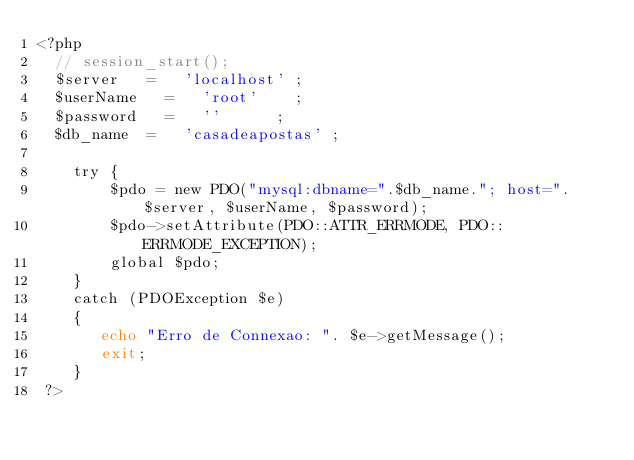Convert code to text. <code><loc_0><loc_0><loc_500><loc_500><_PHP_><?php
	// session_start();
	$server 	= 	'localhost'	;
	$userName 	= 	'root'		;
	$password 	= 	''			;
	$db_name 	= 	'casadeapostas'	;
    
    try {
        $pdo = new PDO("mysql:dbname=".$db_name."; host=".$server, $userName, $password);
        $pdo->setAttribute(PDO::ATTR_ERRMODE, PDO::ERRMODE_EXCEPTION);
        global $pdo;
    } 
    catch (PDOException $e) 
    {
       echo "Erro de Connexao: ". $e->getMessage();
       exit;
    }
 ?> </code> 